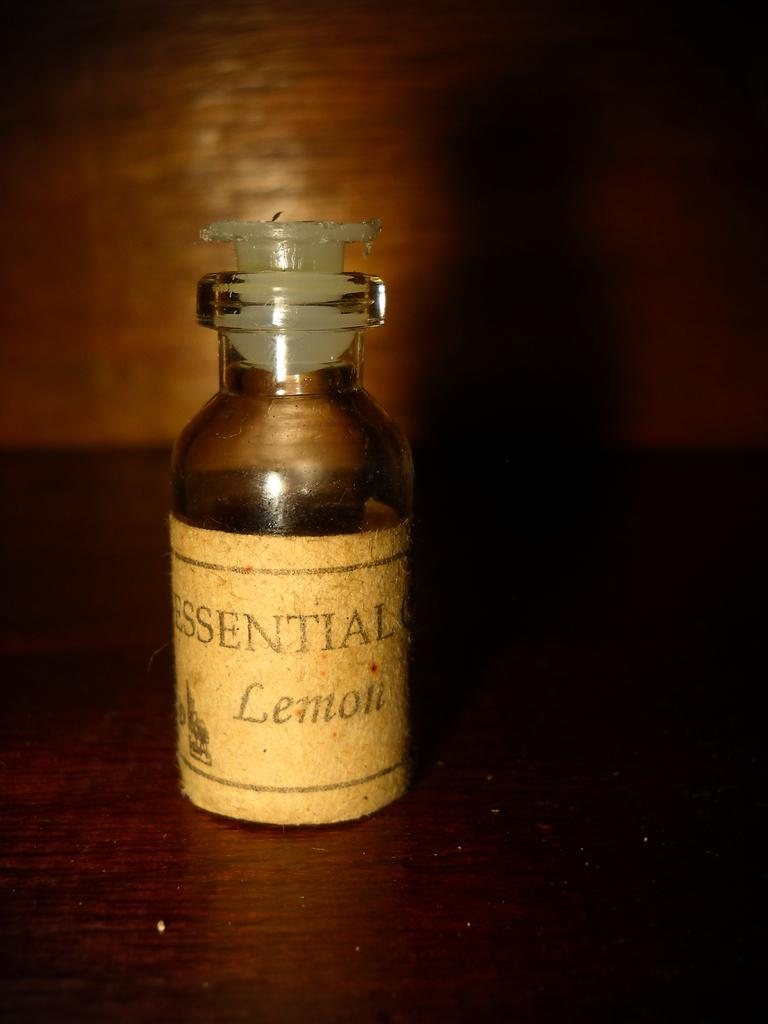Provide a one-sentence caption for the provided image. A bottle of essential oils with the label Lemon. 